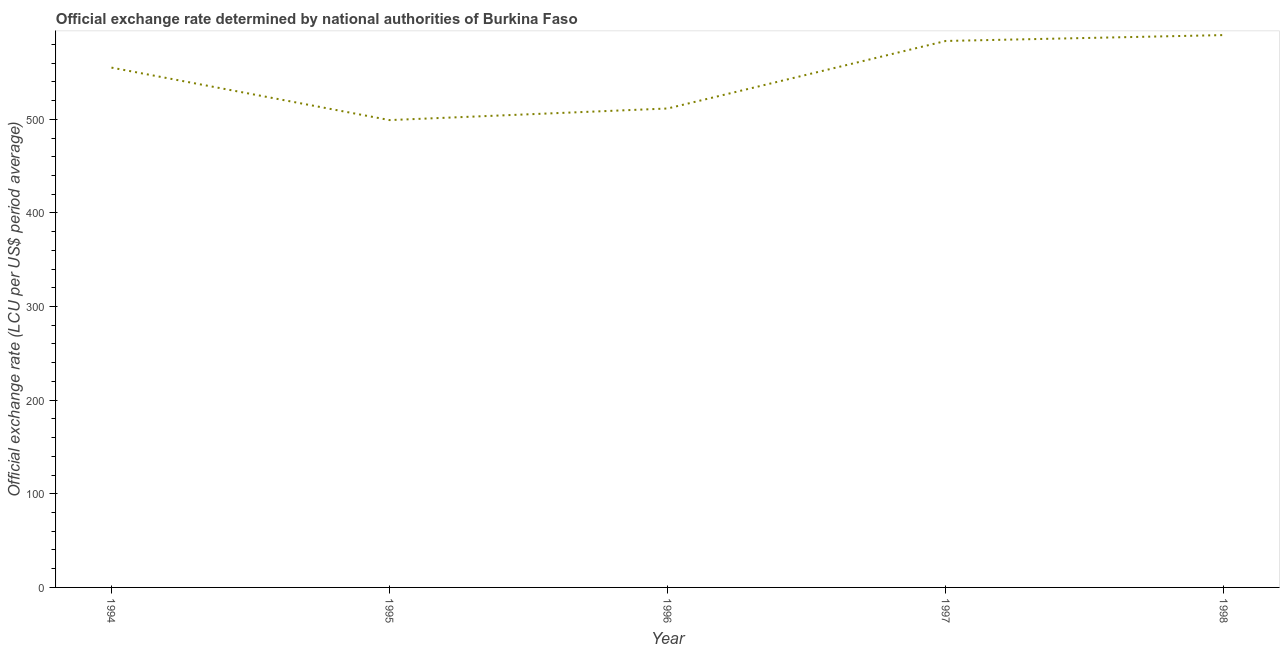What is the official exchange rate in 1994?
Give a very brief answer. 555.2. Across all years, what is the maximum official exchange rate?
Your response must be concise. 589.95. Across all years, what is the minimum official exchange rate?
Provide a short and direct response. 499.15. In which year was the official exchange rate maximum?
Offer a terse response. 1998. In which year was the official exchange rate minimum?
Make the answer very short. 1995. What is the sum of the official exchange rate?
Keep it short and to the point. 2739.53. What is the difference between the official exchange rate in 1995 and 1997?
Ensure brevity in your answer.  -84.52. What is the average official exchange rate per year?
Your answer should be very brief. 547.91. What is the median official exchange rate?
Offer a very short reply. 555.2. Do a majority of the years between 1998 and 1997 (inclusive) have official exchange rate greater than 500 ?
Ensure brevity in your answer.  No. What is the ratio of the official exchange rate in 1994 to that in 1998?
Your response must be concise. 0.94. What is the difference between the highest and the second highest official exchange rate?
Ensure brevity in your answer.  6.28. Is the sum of the official exchange rate in 1994 and 1996 greater than the maximum official exchange rate across all years?
Keep it short and to the point. Yes. What is the difference between the highest and the lowest official exchange rate?
Make the answer very short. 90.8. In how many years, is the official exchange rate greater than the average official exchange rate taken over all years?
Offer a very short reply. 3. Does the graph contain grids?
Your answer should be very brief. No. What is the title of the graph?
Your answer should be very brief. Official exchange rate determined by national authorities of Burkina Faso. What is the label or title of the X-axis?
Your response must be concise. Year. What is the label or title of the Y-axis?
Provide a short and direct response. Official exchange rate (LCU per US$ period average). What is the Official exchange rate (LCU per US$ period average) in 1994?
Keep it short and to the point. 555.2. What is the Official exchange rate (LCU per US$ period average) of 1995?
Your answer should be compact. 499.15. What is the Official exchange rate (LCU per US$ period average) in 1996?
Your answer should be very brief. 511.55. What is the Official exchange rate (LCU per US$ period average) of 1997?
Give a very brief answer. 583.67. What is the Official exchange rate (LCU per US$ period average) in 1998?
Ensure brevity in your answer.  589.95. What is the difference between the Official exchange rate (LCU per US$ period average) in 1994 and 1995?
Your response must be concise. 56.06. What is the difference between the Official exchange rate (LCU per US$ period average) in 1994 and 1996?
Offer a very short reply. 43.65. What is the difference between the Official exchange rate (LCU per US$ period average) in 1994 and 1997?
Your answer should be compact. -28.46. What is the difference between the Official exchange rate (LCU per US$ period average) in 1994 and 1998?
Provide a short and direct response. -34.75. What is the difference between the Official exchange rate (LCU per US$ period average) in 1995 and 1996?
Offer a terse response. -12.4. What is the difference between the Official exchange rate (LCU per US$ period average) in 1995 and 1997?
Keep it short and to the point. -84.52. What is the difference between the Official exchange rate (LCU per US$ period average) in 1995 and 1998?
Make the answer very short. -90.8. What is the difference between the Official exchange rate (LCU per US$ period average) in 1996 and 1997?
Offer a terse response. -72.12. What is the difference between the Official exchange rate (LCU per US$ period average) in 1996 and 1998?
Ensure brevity in your answer.  -78.4. What is the difference between the Official exchange rate (LCU per US$ period average) in 1997 and 1998?
Provide a succinct answer. -6.28. What is the ratio of the Official exchange rate (LCU per US$ period average) in 1994 to that in 1995?
Offer a terse response. 1.11. What is the ratio of the Official exchange rate (LCU per US$ period average) in 1994 to that in 1996?
Ensure brevity in your answer.  1.08. What is the ratio of the Official exchange rate (LCU per US$ period average) in 1994 to that in 1997?
Your answer should be compact. 0.95. What is the ratio of the Official exchange rate (LCU per US$ period average) in 1994 to that in 1998?
Give a very brief answer. 0.94. What is the ratio of the Official exchange rate (LCU per US$ period average) in 1995 to that in 1996?
Give a very brief answer. 0.98. What is the ratio of the Official exchange rate (LCU per US$ period average) in 1995 to that in 1997?
Provide a succinct answer. 0.85. What is the ratio of the Official exchange rate (LCU per US$ period average) in 1995 to that in 1998?
Ensure brevity in your answer.  0.85. What is the ratio of the Official exchange rate (LCU per US$ period average) in 1996 to that in 1997?
Keep it short and to the point. 0.88. What is the ratio of the Official exchange rate (LCU per US$ period average) in 1996 to that in 1998?
Keep it short and to the point. 0.87. 